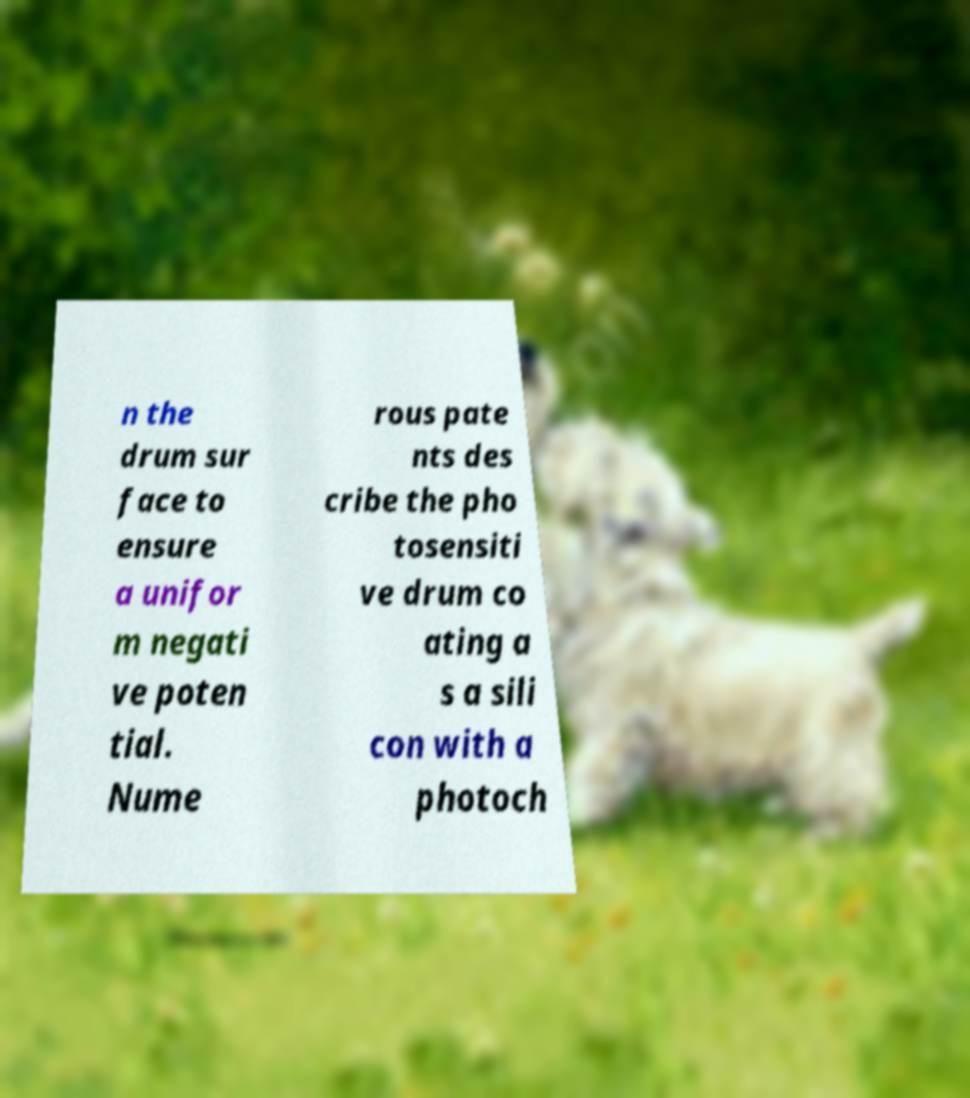I need the written content from this picture converted into text. Can you do that? n the drum sur face to ensure a unifor m negati ve poten tial. Nume rous pate nts des cribe the pho tosensiti ve drum co ating a s a sili con with a photoch 